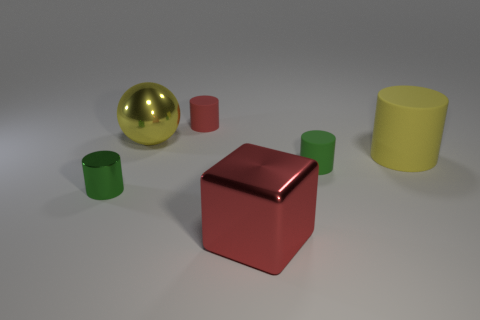Add 1 small objects. How many objects exist? 7 Subtract all small red matte cylinders. How many cylinders are left? 3 Subtract all cylinders. How many objects are left? 2 Add 5 big cylinders. How many big cylinders exist? 6 Subtract all red cylinders. How many cylinders are left? 3 Subtract 0 purple spheres. How many objects are left? 6 Subtract 1 cylinders. How many cylinders are left? 3 Subtract all purple blocks. Subtract all red balls. How many blocks are left? 1 Subtract all brown balls. How many cyan cylinders are left? 0 Subtract all small red cubes. Subtract all yellow metal objects. How many objects are left? 5 